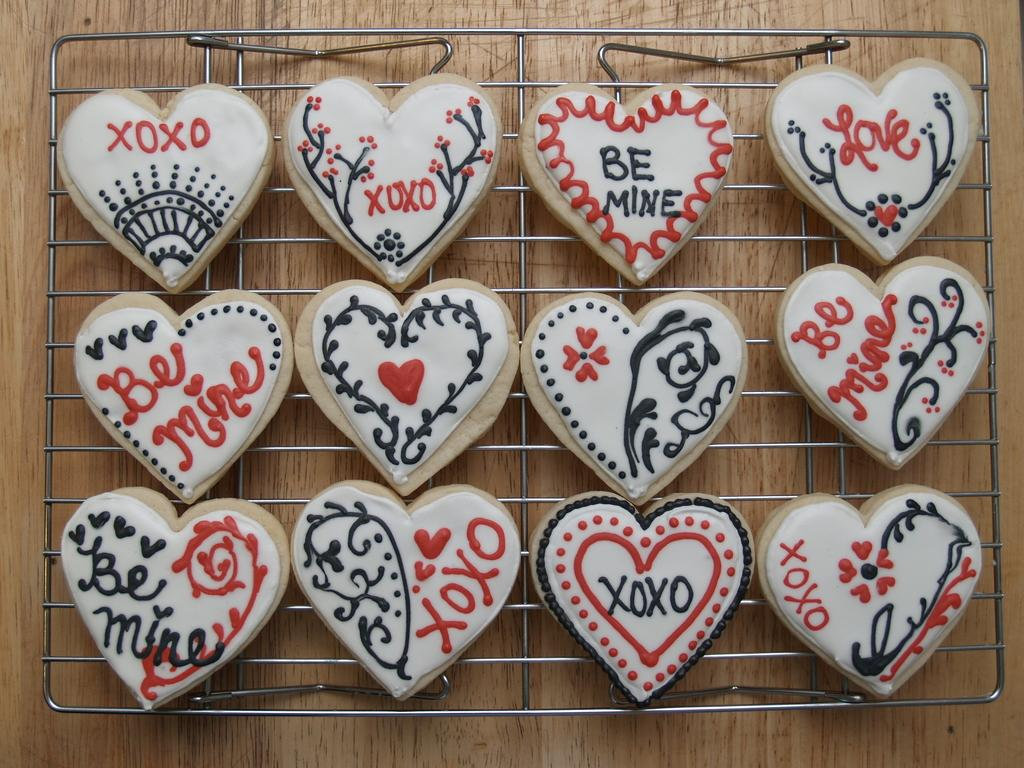What color are the objects in the image? The objects in the image are white. Where are the white objects located? The white objects are on grills. What can be seen on the surface of the white objects? There are designs visible on the white objects. Is there any text present on the white objects? Yes, there is writing on the white objects. What type of stew is being prepared on the grills in the image? There is no stew visible in the image; it only shows white objects with designs and writing on grills. 